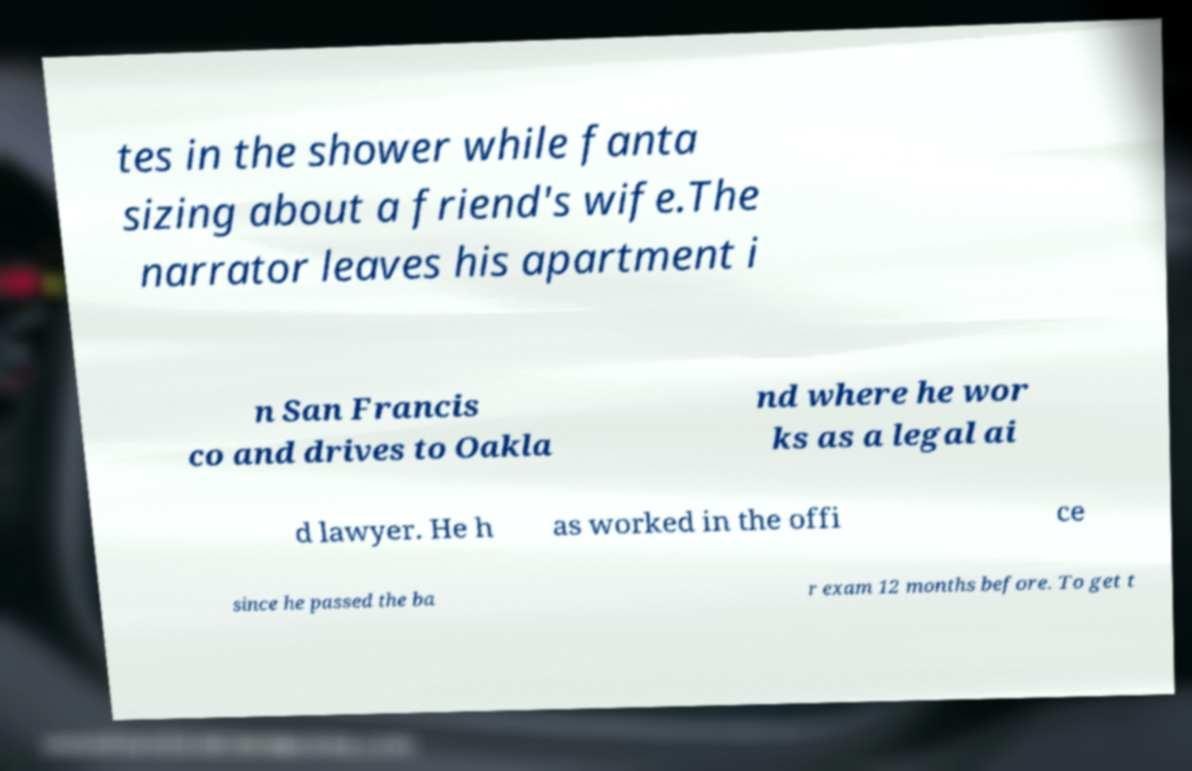Please identify and transcribe the text found in this image. tes in the shower while fanta sizing about a friend's wife.The narrator leaves his apartment i n San Francis co and drives to Oakla nd where he wor ks as a legal ai d lawyer. He h as worked in the offi ce since he passed the ba r exam 12 months before. To get t 